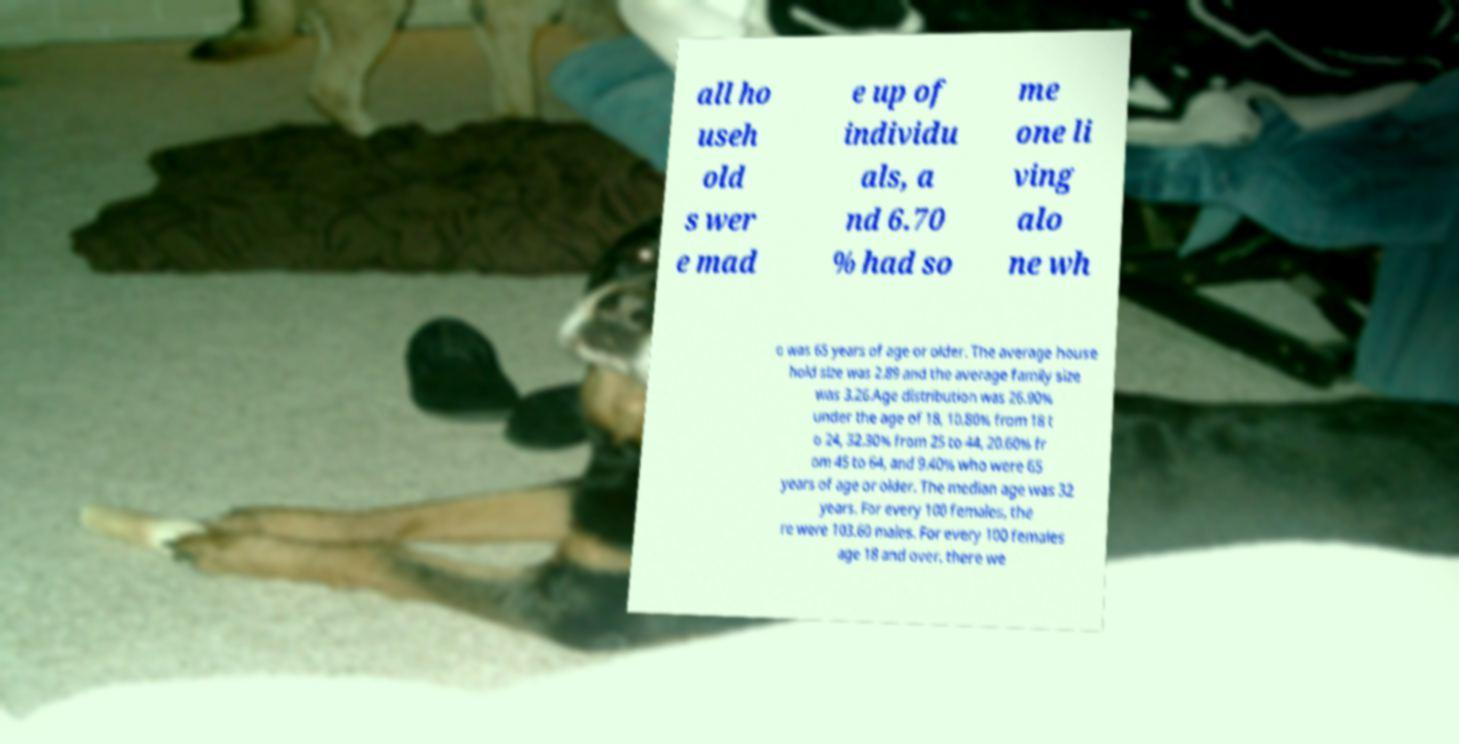Could you assist in decoding the text presented in this image and type it out clearly? all ho useh old s wer e mad e up of individu als, a nd 6.70 % had so me one li ving alo ne wh o was 65 years of age or older. The average house hold size was 2.89 and the average family size was 3.26.Age distribution was 26.90% under the age of 18, 10.80% from 18 t o 24, 32.30% from 25 to 44, 20.60% fr om 45 to 64, and 9.40% who were 65 years of age or older. The median age was 32 years. For every 100 females, the re were 103.60 males. For every 100 females age 18 and over, there we 